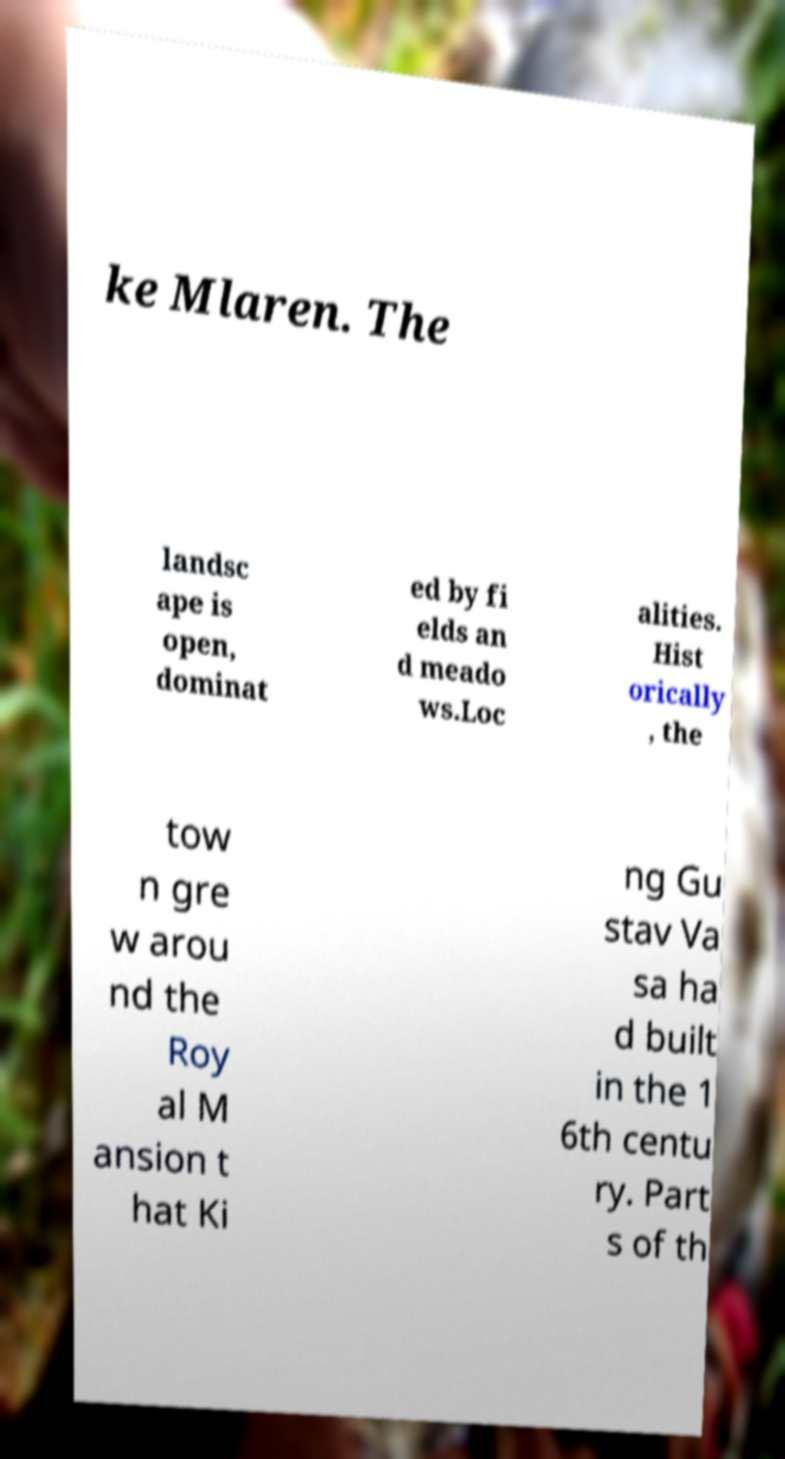Can you accurately transcribe the text from the provided image for me? ke Mlaren. The landsc ape is open, dominat ed by fi elds an d meado ws.Loc alities. Hist orically , the tow n gre w arou nd the Roy al M ansion t hat Ki ng Gu stav Va sa ha d built in the 1 6th centu ry. Part s of th 